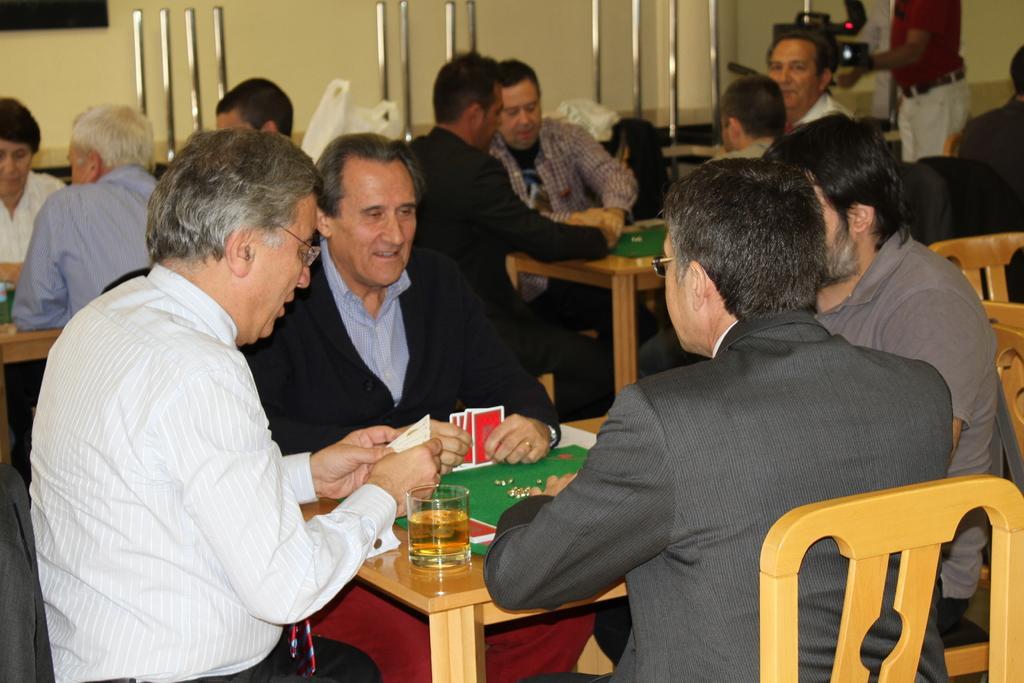Please provide a concise description of this image. In this image it seems like there are people who are playing the cards. There are four people sitting around the table. On the table there is glass,cards and mat. 